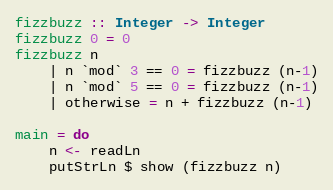<code> <loc_0><loc_0><loc_500><loc_500><_Haskell_>fizzbuzz :: Integer -> Integer
fizzbuzz 0 = 0
fizzbuzz n
    | n `mod` 3 == 0 = fizzbuzz (n-1)
    | n `mod` 5 == 0 = fizzbuzz (n-1)
    | otherwise = n + fizzbuzz (n-1)

main = do
    n <- readLn
    putStrLn $ show (fizzbuzz n)</code> 